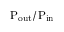<formula> <loc_0><loc_0><loc_500><loc_500>P _ { o u t } / P _ { i n }</formula> 